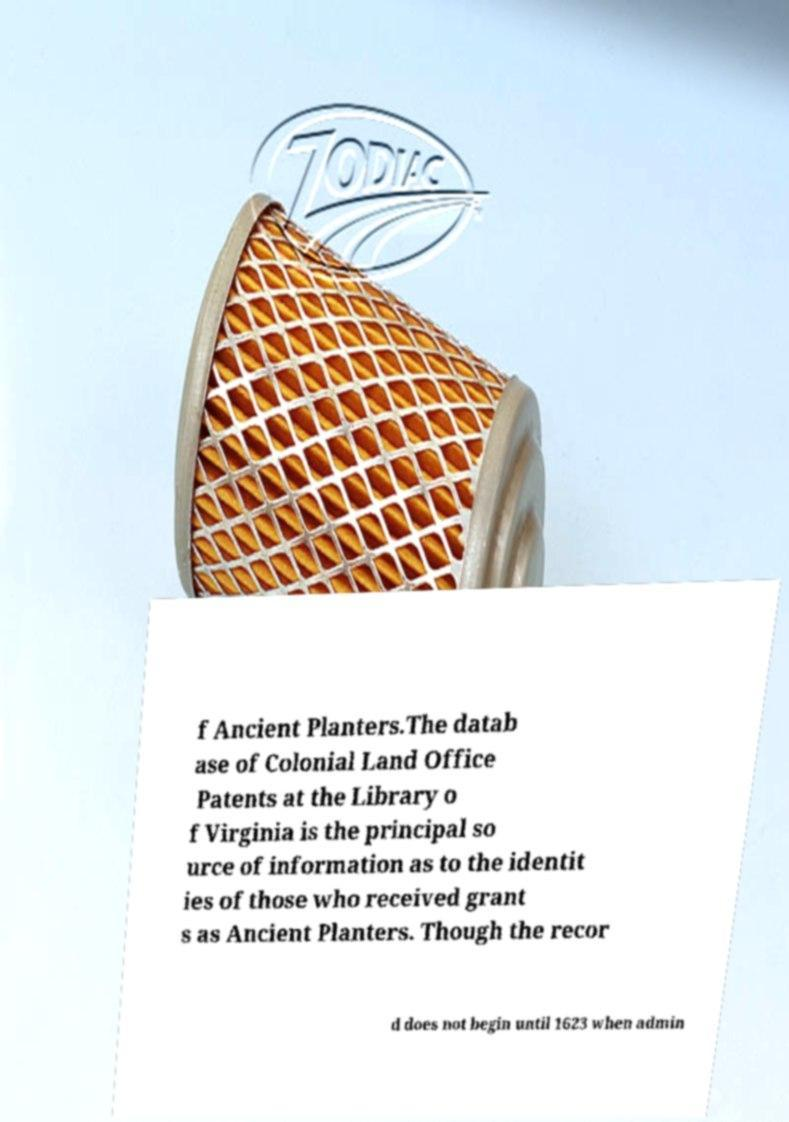Could you extract and type out the text from this image? f Ancient Planters.The datab ase of Colonial Land Office Patents at the Library o f Virginia is the principal so urce of information as to the identit ies of those who received grant s as Ancient Planters. Though the recor d does not begin until 1623 when admin 